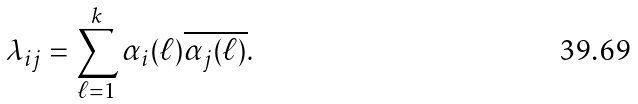Convert formula to latex. <formula><loc_0><loc_0><loc_500><loc_500>\lambda _ { i j } = \sum _ { \ell = 1 } ^ { k } \alpha _ { i } ( \ell ) \overline { \alpha _ { j } ( \ell ) } .</formula> 